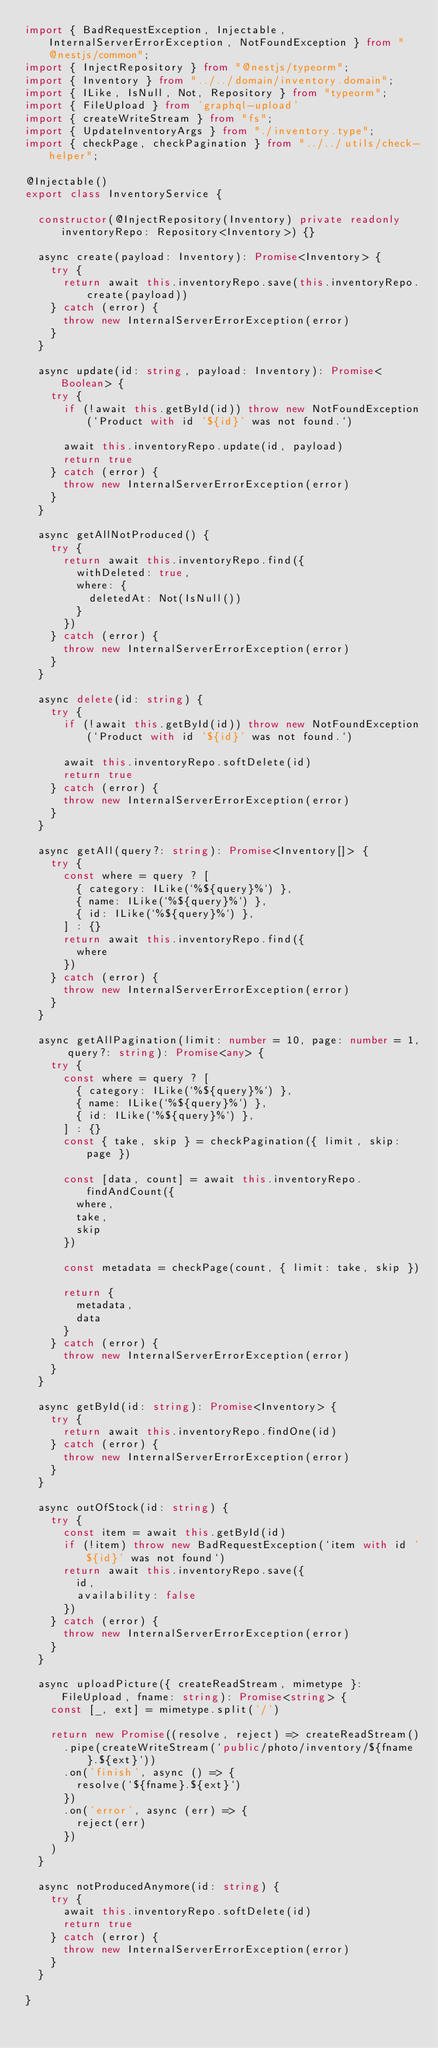Convert code to text. <code><loc_0><loc_0><loc_500><loc_500><_TypeScript_>import { BadRequestException, Injectable, InternalServerErrorException, NotFoundException } from "@nestjs/common";
import { InjectRepository } from "@nestjs/typeorm";
import { Inventory } from "../../domain/inventory.domain";
import { ILike, IsNull, Not, Repository } from "typeorm";
import { FileUpload } from 'graphql-upload'
import { createWriteStream } from "fs";
import { UpdateInventoryArgs } from "./inventory.type";
import { checkPage, checkPagination } from "../../utils/check-helper";

@Injectable()
export class InventoryService {

  constructor(@InjectRepository(Inventory) private readonly inventoryRepo: Repository<Inventory>) {}

  async create(payload: Inventory): Promise<Inventory> {
    try {
      return await this.inventoryRepo.save(this.inventoryRepo.create(payload))
    } catch (error) {
      throw new InternalServerErrorException(error)
    }
  }

  async update(id: string, payload: Inventory): Promise<Boolean> {
    try {
      if (!await this.getById(id)) throw new NotFoundException(`Product with id '${id}' was not found.`)

      await this.inventoryRepo.update(id, payload)
      return true
    } catch (error) {
      throw new InternalServerErrorException(error)
    }
  }

  async getAllNotProduced() {
    try {
      return await this.inventoryRepo.find({
        withDeleted: true,
        where: {
          deletedAt: Not(IsNull())
        }
      })
    } catch (error) {
      throw new InternalServerErrorException(error)
    }
  }

  async delete(id: string) {
    try {
      if (!await this.getById(id)) throw new NotFoundException(`Product with id '${id}' was not found.`)

      await this.inventoryRepo.softDelete(id)
      return true
    } catch (error) {
      throw new InternalServerErrorException(error)
    }
  }

  async getAll(query?: string): Promise<Inventory[]> {
    try {
      const where = query ? [
        { category: ILike(`%${query}%`) },
        { name: ILike(`%${query}%`) },
        { id: ILike(`%${query}%`) },
      ] : {}
      return await this.inventoryRepo.find({
        where
      })
    } catch (error) {
      throw new InternalServerErrorException(error)
    }
  }

  async getAllPagination(limit: number = 10, page: number = 1, query?: string): Promise<any> {
    try {
      const where = query ? [
        { category: ILike(`%${query}%`) },
        { name: ILike(`%${query}%`) },
        { id: ILike(`%${query}%`) },
      ] : {}
      const { take, skip } = checkPagination({ limit, skip: page })

      const [data, count] = await this.inventoryRepo.findAndCount({
        where,
        take,
        skip
      })

      const metadata = checkPage(count, { limit: take, skip })

      return {
        metadata,
        data
      }
    } catch (error) {
      throw new InternalServerErrorException(error)
    }
  }

  async getById(id: string): Promise<Inventory> {
    try {
      return await this.inventoryRepo.findOne(id)
    } catch (error) {
      throw new InternalServerErrorException(error)
    }
  }

  async outOfStock(id: string) {
    try {
      const item = await this.getById(id)
      if (!item) throw new BadRequestException(`item with id '${id}' was not found`)
      return await this.inventoryRepo.save({
        id,
        availability: false
      })
    } catch (error) {
      throw new InternalServerErrorException(error)
    }
  }

  async uploadPicture({ createReadStream, mimetype }: FileUpload, fname: string): Promise<string> {
    const [_, ext] = mimetype.split('/')

    return new Promise((resolve, reject) => createReadStream()
      .pipe(createWriteStream(`public/photo/inventory/${fname}.${ext}`))
      .on('finish', async () => {
        resolve(`${fname}.${ext}`)
      })
      .on('error', async (err) => {
        reject(err)
      })
    )
  }

  async notProducedAnymore(id: string) {
    try {
      await this.inventoryRepo.softDelete(id)
      return true
    } catch (error) {
      throw new InternalServerErrorException(error)
    }
  }

}
</code> 